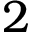<formula> <loc_0><loc_0><loc_500><loc_500>2</formula> 